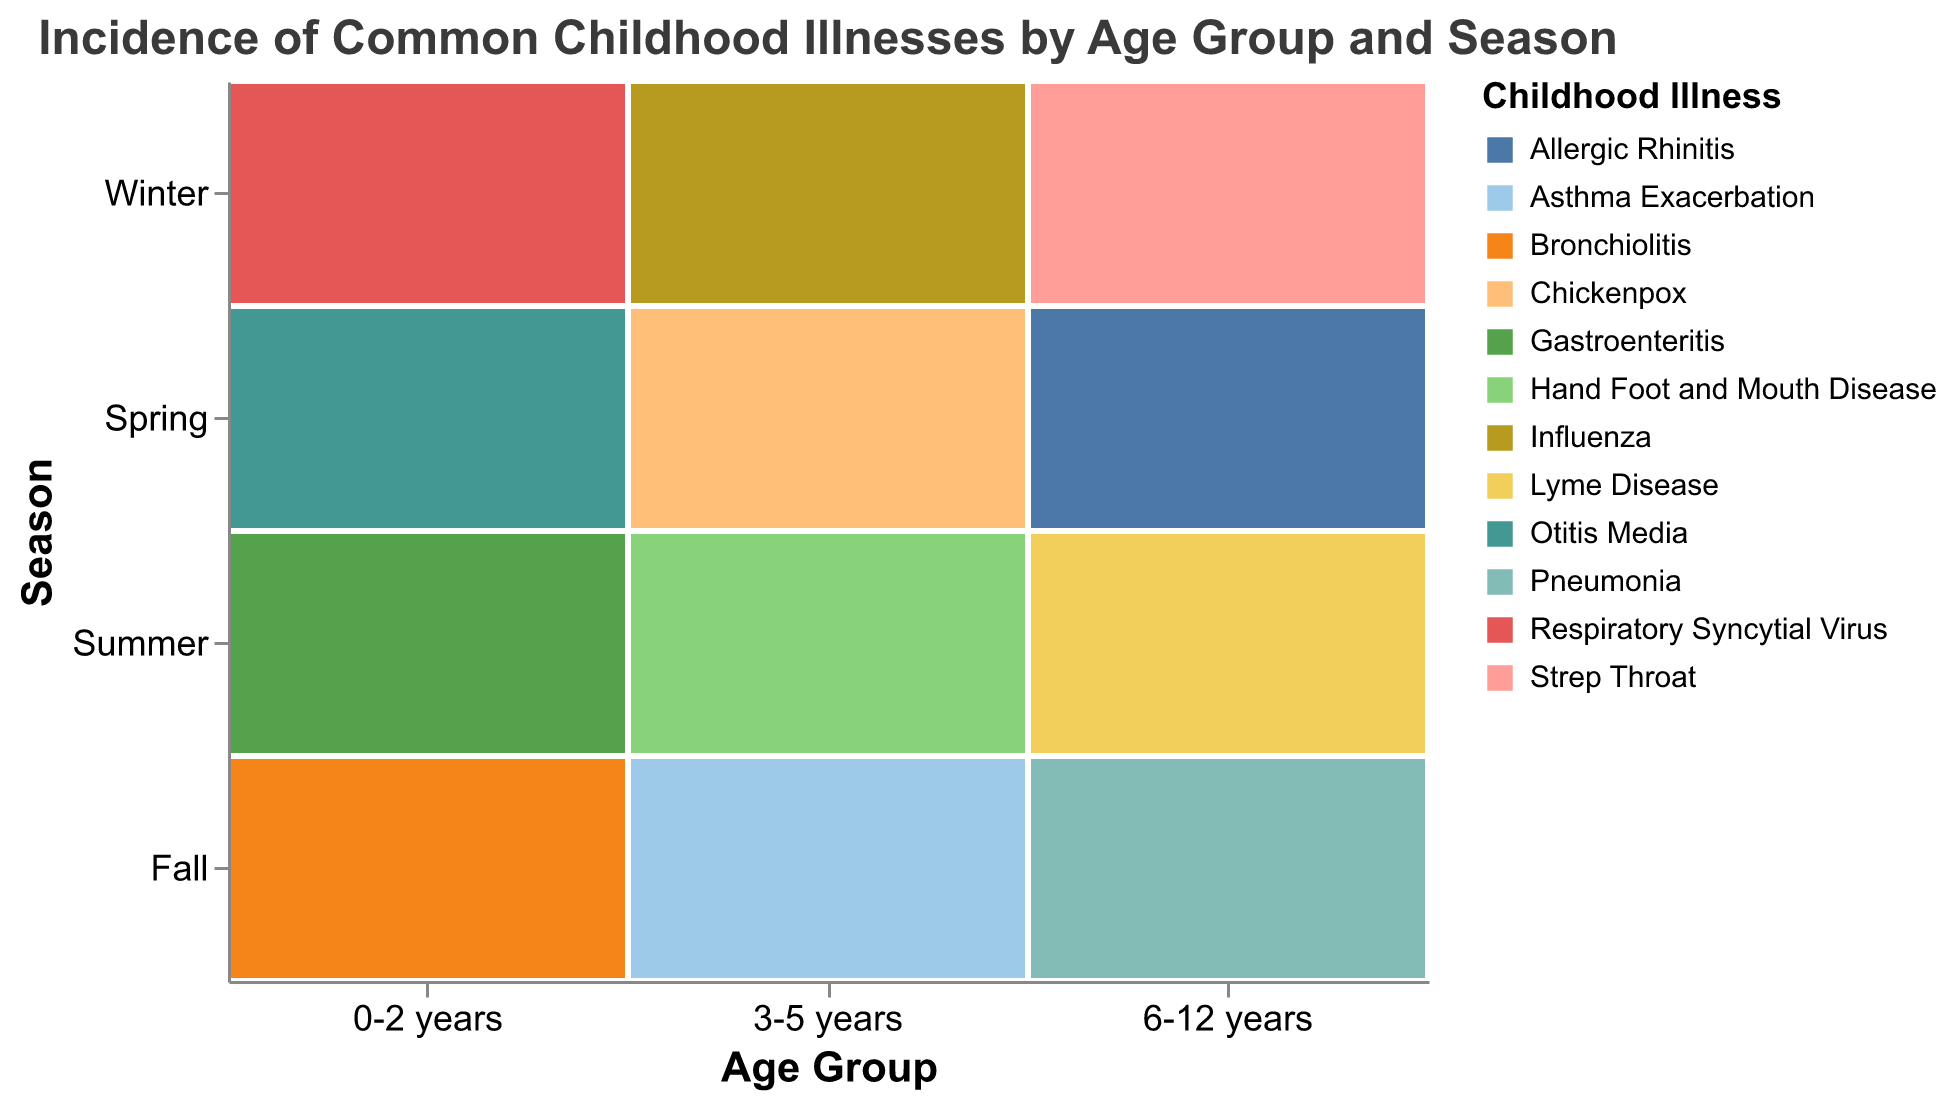What is the title of the plot? The title of the plot is located at the top of the figure.
Answer: Incidence of Common Childhood Illnesses by Age Group and Season Which age group experiences the highest incidence of illness in Winter? Look at the "Winter" row and identify the largest rectangle within each age group.
Answer: 0-2 years In which season does the age group 6-12 years experience the lowest incidence of illness? Check the sizes of the rectangles corresponding to 6-12 years across all seasons and identify the smallest one.
Answer: Summer What illness has the highest incidence in the 3-5 years age group during Winter? Look for the "3-5 years" column, and within that, check the rectangle for Winter to see which illness is labeled.
Answer: Influenza How does the incidence of illness in the 0-2 years age group during Fall compare to Summer? Compare the rectangles for Fall and Summer in the 0-2 years age group by identifying and comparing their sizes.
Answer: Higher in Fall Compare the sum of incidence rates for Otitis Media and Bronchiolitis in the 0-2 years age group. Sum the incidences of Otitis Media (Spring) and Bronchiolitis (Fall) within the 0-2 years age group.
Answer: 570 Which illness has the most varied incidence across different seasons in the 6-12 years age group? Examine the sizes of the rectangles for each illness in the "6-12 years" column and see which one varies the most between the seasons.
Answer: Allergic Rhinitis Which season shows the highest incidence of illness across all ages? Check the sum of the sizes of rectangles in each season row and identify the highest one.
Answer: Winter 